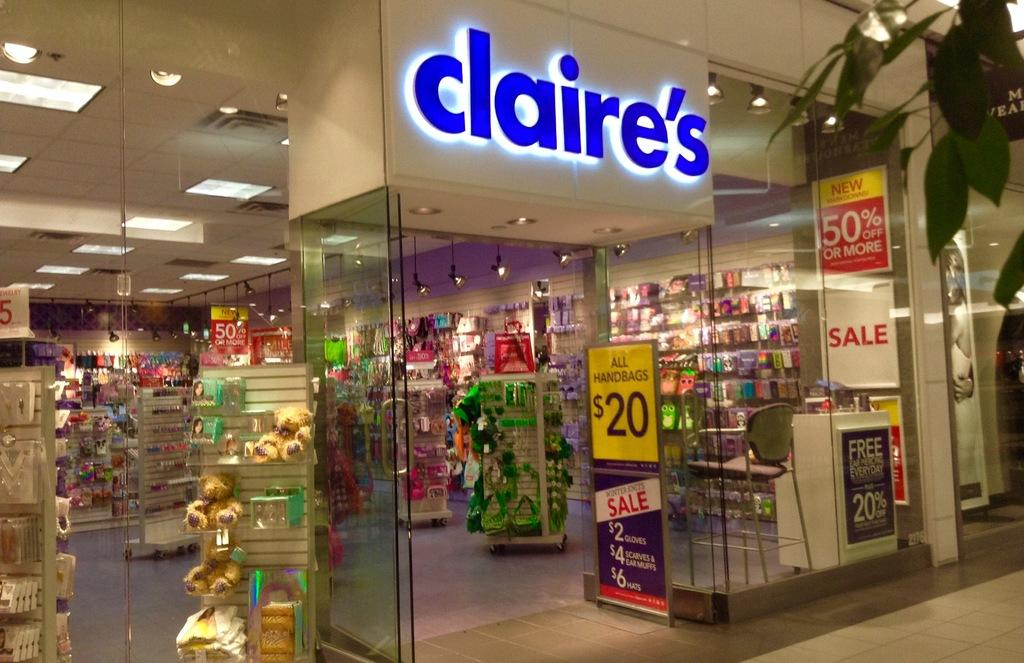<image>
Describe the image concisely. A store called claire's with various sales going on 